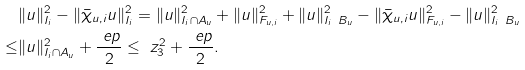Convert formula to latex. <formula><loc_0><loc_0><loc_500><loc_500>& \| u \| ^ { 2 } _ { I _ { i } } - \| \bar { \chi } _ { u , i } u \| ^ { 2 } _ { I _ { i } } = \| u \| ^ { 2 } _ { I _ { i } \cap A _ { u } } + \| u \| ^ { 2 } _ { F _ { u , i } } + \| u \| ^ { 2 } _ { I _ { i } \ B _ { u } } - \| \bar { \chi } _ { u , i } u \| ^ { 2 } _ { F _ { u , i } } - \| u \| ^ { 2 } _ { I _ { i } \ B _ { u } } \\ \leq & \| u \| ^ { 2 } _ { I _ { i } \cap A _ { u } } + \frac { \ e p } { 2 } \leq \ z ^ { 2 } _ { 3 } + \frac { \ e p } { 2 } .</formula> 